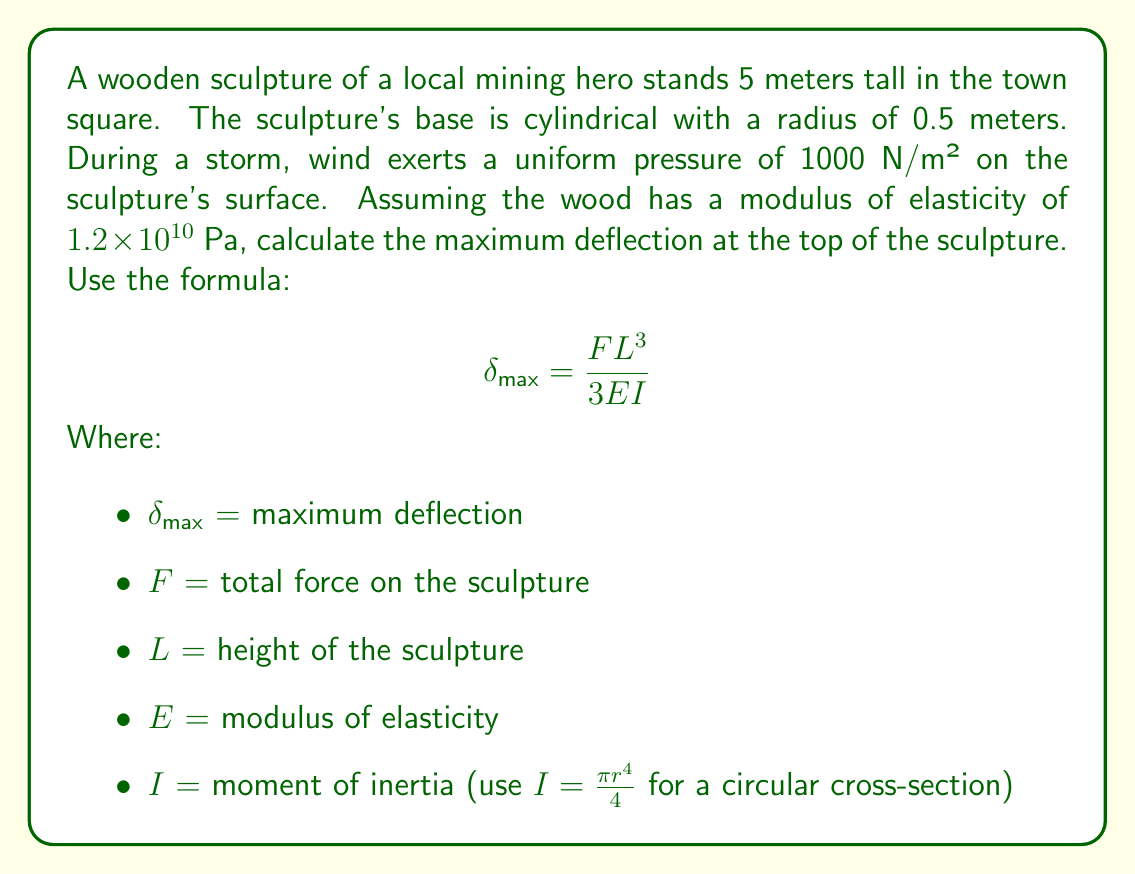What is the answer to this math problem? To solve this problem, we'll follow these steps:

1) Calculate the total force $(F)$ on the sculpture:
   Area of the sculpture facing the wind = $5 \text{ m} \times 1 \text{ m} = 5 \text{ m}^2$
   $F = 1000 \text{ N/m}^2 \times 5 \text{ m}^2 = 5000 \text{ N}$

2) Calculate the moment of inertia $(I)$ for the circular base:
   $I = \frac{\pi r^4}{4} = \frac{\pi (0.5 \text{ m})^4}{4} = 0.0030679 \text{ m}^4$

3) We have:
   $F = 5000 \text{ N}$
   $L = 5 \text{ m}$
   $E = 1.2 \times 10^{10} \text{ Pa}$
   $I = 0.0030679 \text{ m}^4$

4) Substitute these values into the deflection formula:
   $$ \delta_{max} = \frac{5000 \text{ N} \times (5 \text{ m})^3}{3 \times 1.2 \times 10^{10} \text{ Pa} \times 0.0030679 \text{ m}^4} $$

5) Calculate:
   $$ \delta_{max} = \frac{625000}{1104444} = 0.5659 \text{ m} $$

Therefore, the maximum deflection at the top of the sculpture is approximately 0.5659 meters or 56.59 cm.
Answer: 56.59 cm 